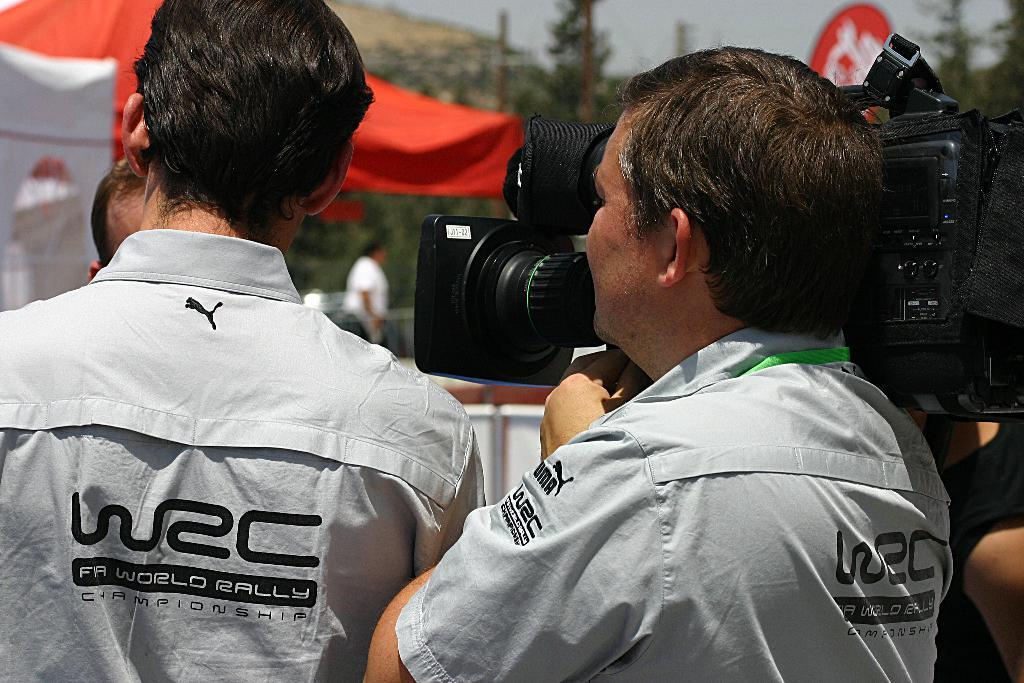How many people are in the image? There are two persons standing in the image. What are the people wearing? Both persons are wearing white shirts. What is one of the men holding? One of the men is holding a camera. What can be seen in the background of the image? There are trees visible in the distance. What color is the tent in the image? There is a red tent in the image. What type of pipe is being used by the person in the image? There is no pipe present in the image; both persons are wearing white shirts and one is holding a camera. 